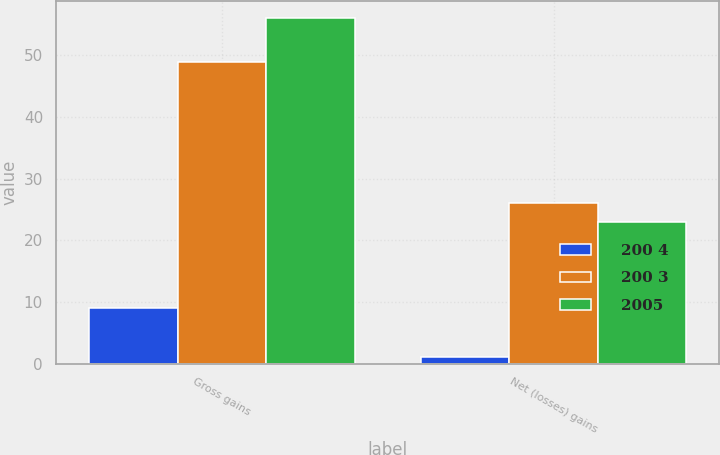Convert chart. <chart><loc_0><loc_0><loc_500><loc_500><stacked_bar_chart><ecel><fcel>Gross gains<fcel>Net (losses) gains<nl><fcel>200 4<fcel>9<fcel>1<nl><fcel>200 3<fcel>49<fcel>26<nl><fcel>2005<fcel>56<fcel>23<nl></chart> 